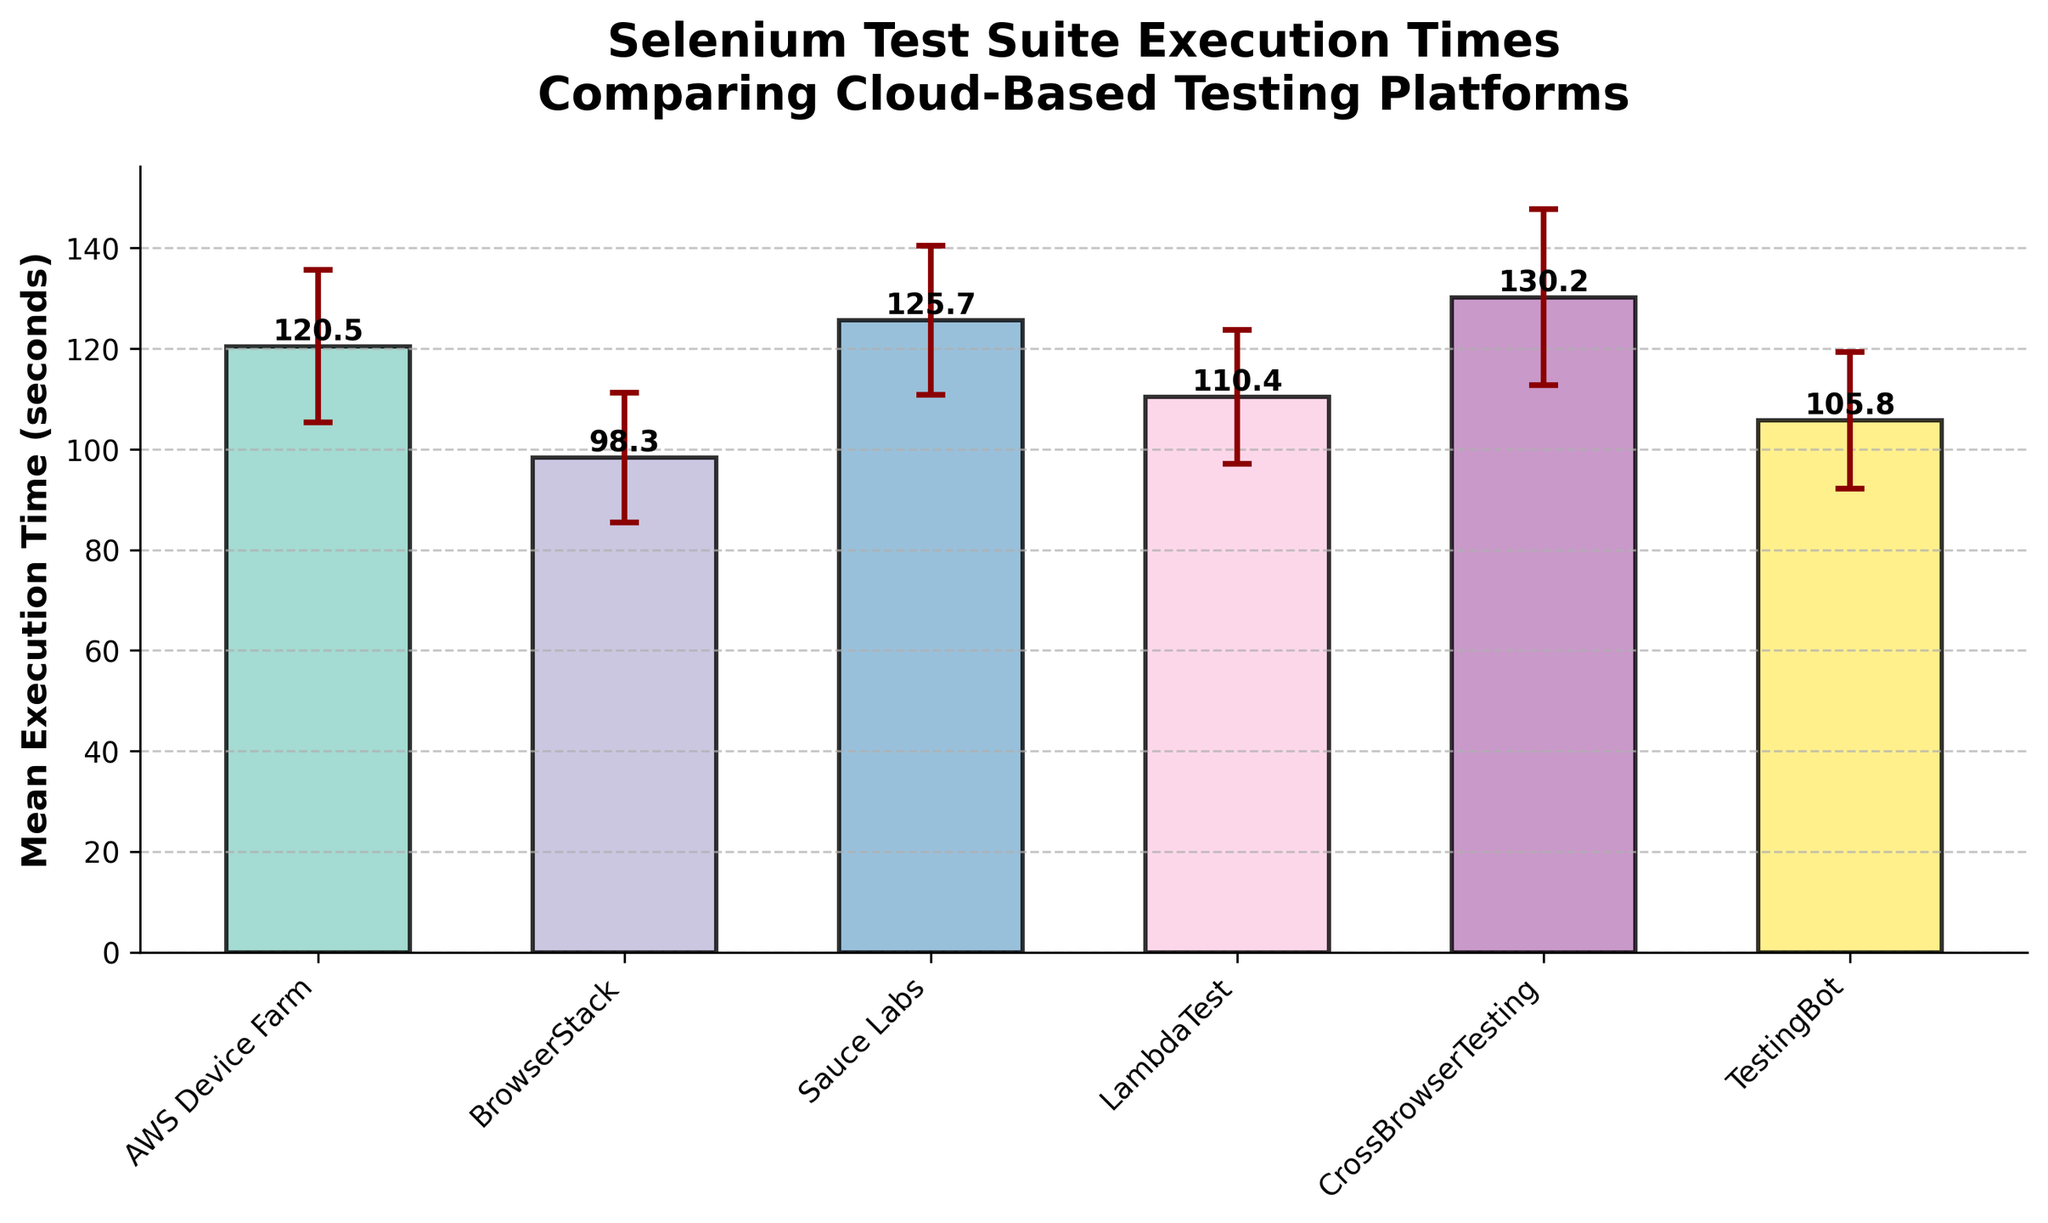Which platform has the shortest mean execution time? The shortest mean execution time can be identified as the lowest bar in the plot. By examining the bars, BrowserStack has the shortest mean execution time of 98.3 seconds.
Answer: BrowserStack How much higher is the mean execution time of Sauce Labs compared to TestingBot? First, identify and extract the mean execution times: Sauce Labs is 125.7 seconds, and TestingBot is 105.8 seconds. Subtract the latter from the former: 125.7 - 105.8 = 19.9 seconds.
Answer: 19.9 seconds Which platform has the highest standard deviation in execution time? The highest standard deviation can be identified by examining the error bars, representing the execution time variability. CrossBrowserTesting has the longest error bar, corresponding to a standard deviation of 17.5 seconds.
Answer: CrossBrowserTesting What's the mean execution time of the platform closest to 110 seconds? By scanning the mean execution times, LambdaTest is close to 110 seconds with an exact mean execution time of 110.4 seconds.
Answer: 110.4 seconds Which platform has the highest mean execution time? The platform with the highest mean execution time is identified by the tallest bar. CrossBrowserTesting has the highest mean execution time of 130.2 seconds.
Answer: CrossBrowserTesting Are there any platforms with overlapping error bars indicating potential non-significant mean execution time differences? Look at the error bars to see if any overlap significantly. For instance, the error bars of Sauce Labs (125.7 ± 14.8) and CrossBrowserTesting (130.2 ± 17.5) overlap, indicating potential non-significance in their mean differences.
Answer: Yes How does the mean execution time of AWS Device Farm compare to the average mean execution time of all platforms? First, compute the average mean execution time of all platforms: (120.5 + 98.3 + 125.7 + 110.4 + 130.2 + 105.8) / 6 ≈ 115.15 seconds. AWS Device Farm's mean execution time is 120.5 seconds, which is higher than the average.
Answer: Higher What is the mean of the standard deviations across all platforms? Add each standard deviation and then divide by the number of platforms: (15.2 + 12.9 + 14.8 + 13.3 + 17.5 + 13.6) / 6 = 87.3 / 6 ≈ 14.55 seconds.
Answer: 14.55 seconds Which platforms have a mean execution time above 120 seconds? By examining the mean execution times, the platforms with values above 120 seconds are AWS Device Farm (120.5), Sauce Labs (125.7), and CrossBrowserTesting (130.2).
Answer: AWS Device Farm, Sauce Labs, CrossBrowserTesting What's the range of execution times for TestingBot considering its standard deviation? TestingBot's mean execution time is 105.8 seconds with a standard deviation of 13.6 seconds. The range is computed as: 105.8 ± 13.6, so the range is approximately [92.2, 119.4] seconds.
Answer: [92.2, 119.4] seconds 